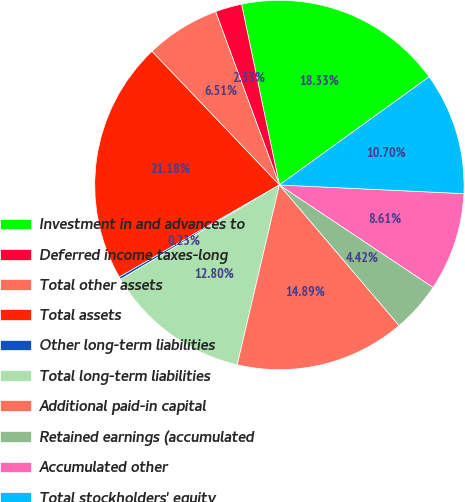Convert chart. <chart><loc_0><loc_0><loc_500><loc_500><pie_chart><fcel>Investment in and advances to<fcel>Deferred income taxes-long<fcel>Total other assets<fcel>Total assets<fcel>Other long-term liabilities<fcel>Total long-term liabilities<fcel>Additional paid-in capital<fcel>Retained earnings (accumulated<fcel>Accumulated other<fcel>Total stockholders' equity<nl><fcel>18.33%<fcel>2.33%<fcel>6.51%<fcel>21.18%<fcel>0.23%<fcel>12.8%<fcel>14.89%<fcel>4.42%<fcel>8.61%<fcel>10.7%<nl></chart> 